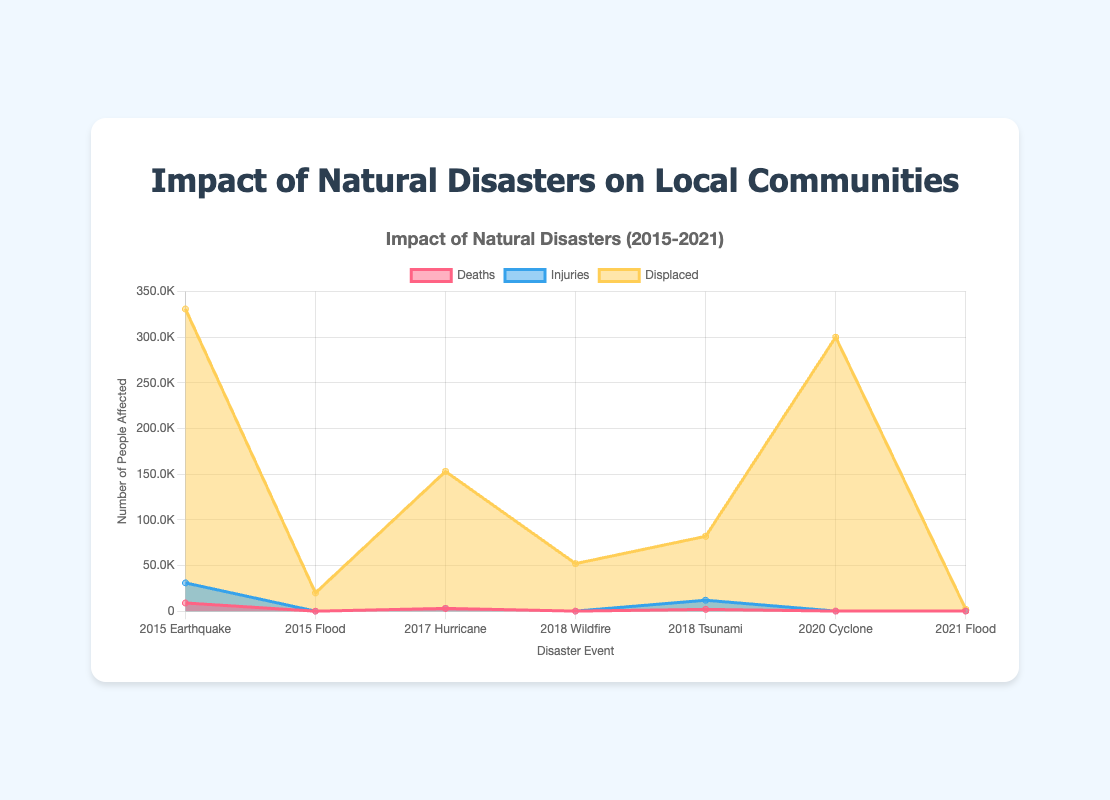What is the title of the area chart? The title is located at the top of the chart, displaying the main subject.
Answer: Impact of Natural Disasters on Local Communities What are the four types of impact measured in the area chart? The legend at the top right of the chart identifies the types of impact.
Answer: Deaths, Injuries, Displaced, Economic Losses Which natural disaster had the highest number of displaced people? By examining the "Displaced" section of the area chart, we can identify which disaster has the highest value in that category.
Answer: 2015 Earthquake (300,000 displaced) How many deaths were caused by the 2015 Flood in South Carolina, USA? Look at the "Deaths" section of the chart and find the value corresponding to the 2015 Flood event.
Answer: 19 deaths Compare the impact of the 2017 Hurricane in Puerto Rico and the 2018 Wildfire in California, USA, in terms of economic losses. Which one caused more damage? Check the economic losses for both disasters in their respective segments on the chart.
Answer: 2017 Hurricane (91 billion vs 16 billion) Summarize the number of deaths caused by all the natural disasters recorded in the chart. Add the number of deaths for all disasters shown in the "Deaths" section of the chart.
Answer: 14,486 deaths On average, how many people were injured annually due to natural disasters from 2015 to 2021? Sum the total number of injuries and divide by the number of years represented. (22000 + 0 + 0 + 10000 + 0 + 0 = 32000; 32000 / 7 years)
Answer: 4,571.43 injuries per year Which year experienced the most variety in natural disasters, and what were they? Identify the year with the highest number of distinct disasters by examining the x-axis labels.
Answer: 2018 (Wildfire and Tsunami) Compare the total number of injuries and the total number of displaced people from all disasters. Which is greater? Sum the total injuries and total displaced columns from the respective "Injuries" and "Displaced" sections of the chart. Analyze and compare the two sums.
Answer: Displaced (418,000 vs 32,000) Which disaster had the least economic loss and what was the amount? Look at the "Economic Losses" section and find the event with the lowest value.
Answer: 2018 Tsunami (1 billion) 